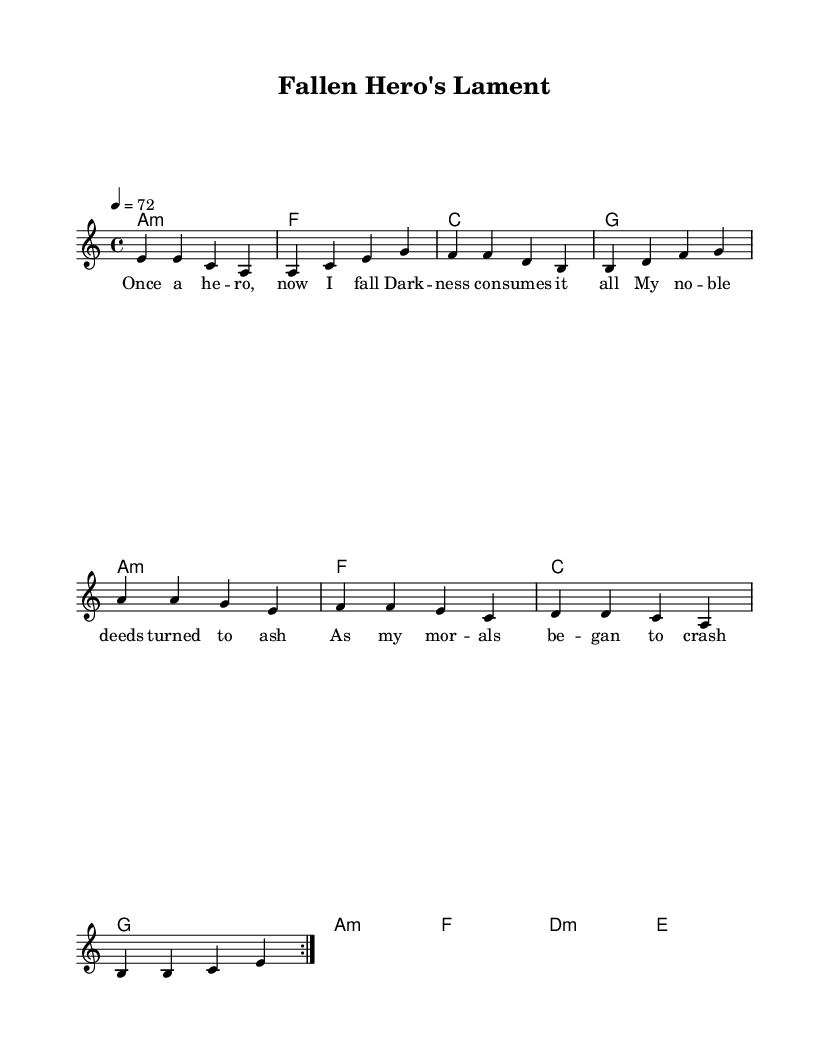What is the key signature of this music? The key signature is indicated by the letter before the main section of the music. Here, it states "a minor," which means all the notes will follow the scale associated with A minor that has no sharps or flats.
Answer: A minor What is the time signature of this music? The time signature is found at the beginning of the score. It is indicated with "4/4", meaning there are four beats in each measure.
Answer: 4/4 What is the tempo marking of this music? The tempo is set at "4 = 72" which means the quarter note should be played at a speed of 72 beats per minute.
Answer: 72 How many measures of melody are repeated in the score? The score mentions a repeated section using the term "volta" which is shorthand for repeats. Here it states "repeat volta 2," meaning the melody section is repeated twice.
Answer: 2 What is the chord for the first measure? The first chord is specified in the chord section. It shows "a1:m," which indicates it is an A minor chord.
Answer: A minor What genre does this music belong to? The context of the music, along with its specific style and lyrical themes of a noble protagonist falling from grace, indicates that it belongs to the reggae genre, particularly focusing on a ballad form.
Answer: Reggae What is the theme of the lyrics in this piece? The lyrics describe a character's downfall, referring to their previous noble status and the consuming nature of darkness, which indicates a theme of tragedy tied to moral decline.
Answer: Fall of a hero 